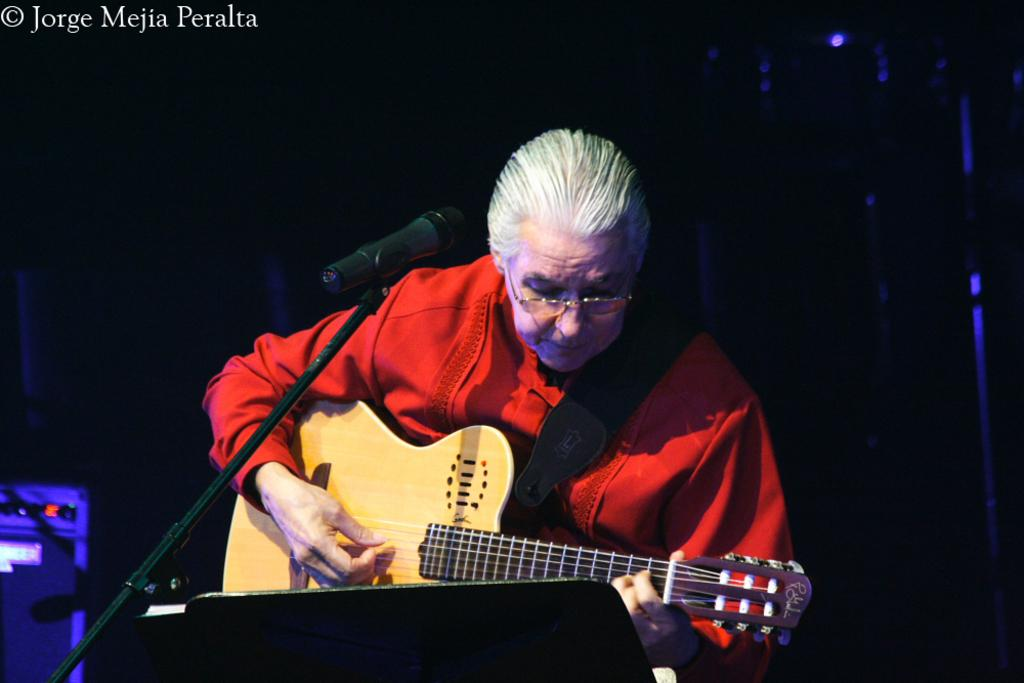Who or what is the main subject of the image? There is a person in the image. What is the person holding in the image? The person is holding a guitar. What object is in front of the person? There is a microphone in front of the person. What type of lock can be seen securing the guitar in the image? There is no lock visible in the image; the person is simply holding the guitar. What kind of exchange is taking place between the person and the microphone in the image? There is no exchange between the person and the microphone in the image; the microphone is simply in front of the person. 